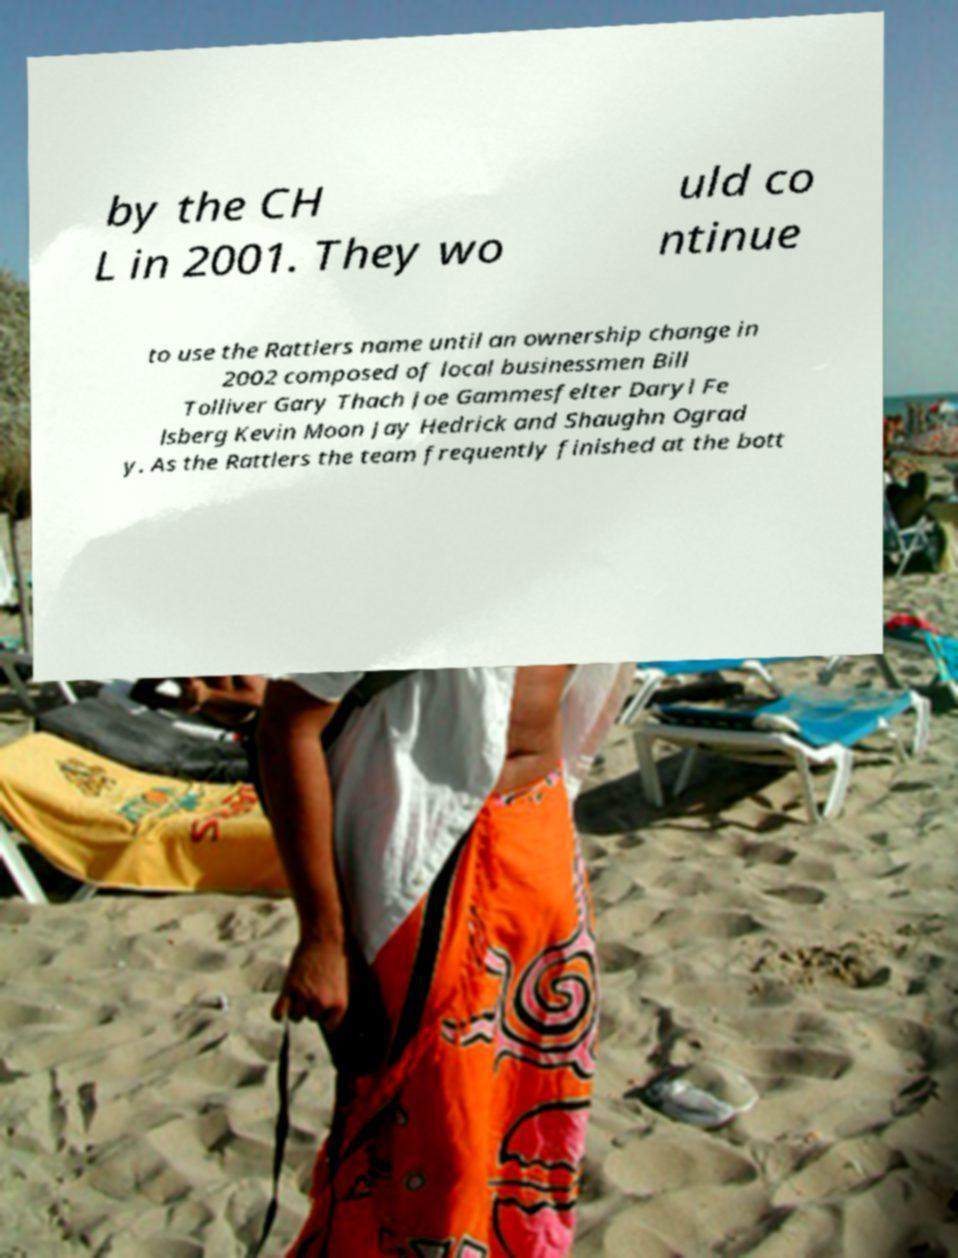For documentation purposes, I need the text within this image transcribed. Could you provide that? by the CH L in 2001. They wo uld co ntinue to use the Rattlers name until an ownership change in 2002 composed of local businessmen Bill Tolliver Gary Thach Joe Gammesfelter Daryl Fe lsberg Kevin Moon Jay Hedrick and Shaughn Ograd y. As the Rattlers the team frequently finished at the bott 